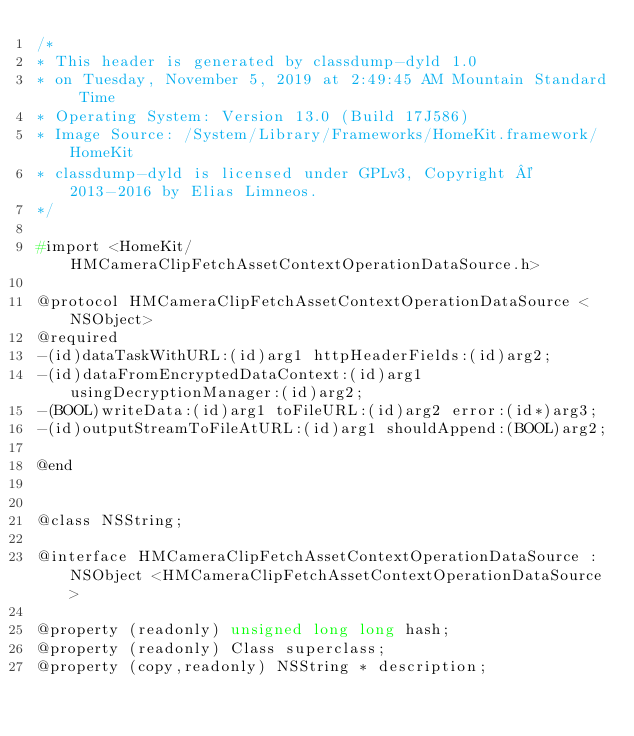Convert code to text. <code><loc_0><loc_0><loc_500><loc_500><_C_>/*
* This header is generated by classdump-dyld 1.0
* on Tuesday, November 5, 2019 at 2:49:45 AM Mountain Standard Time
* Operating System: Version 13.0 (Build 17J586)
* Image Source: /System/Library/Frameworks/HomeKit.framework/HomeKit
* classdump-dyld is licensed under GPLv3, Copyright © 2013-2016 by Elias Limneos.
*/

#import <HomeKit/HMCameraClipFetchAssetContextOperationDataSource.h>

@protocol HMCameraClipFetchAssetContextOperationDataSource <NSObject>
@required
-(id)dataTaskWithURL:(id)arg1 httpHeaderFields:(id)arg2;
-(id)dataFromEncryptedDataContext:(id)arg1 usingDecryptionManager:(id)arg2;
-(BOOL)writeData:(id)arg1 toFileURL:(id)arg2 error:(id*)arg3;
-(id)outputStreamToFileAtURL:(id)arg1 shouldAppend:(BOOL)arg2;

@end


@class NSString;

@interface HMCameraClipFetchAssetContextOperationDataSource : NSObject <HMCameraClipFetchAssetContextOperationDataSource>

@property (readonly) unsigned long long hash; 
@property (readonly) Class superclass; 
@property (copy,readonly) NSString * description; </code> 